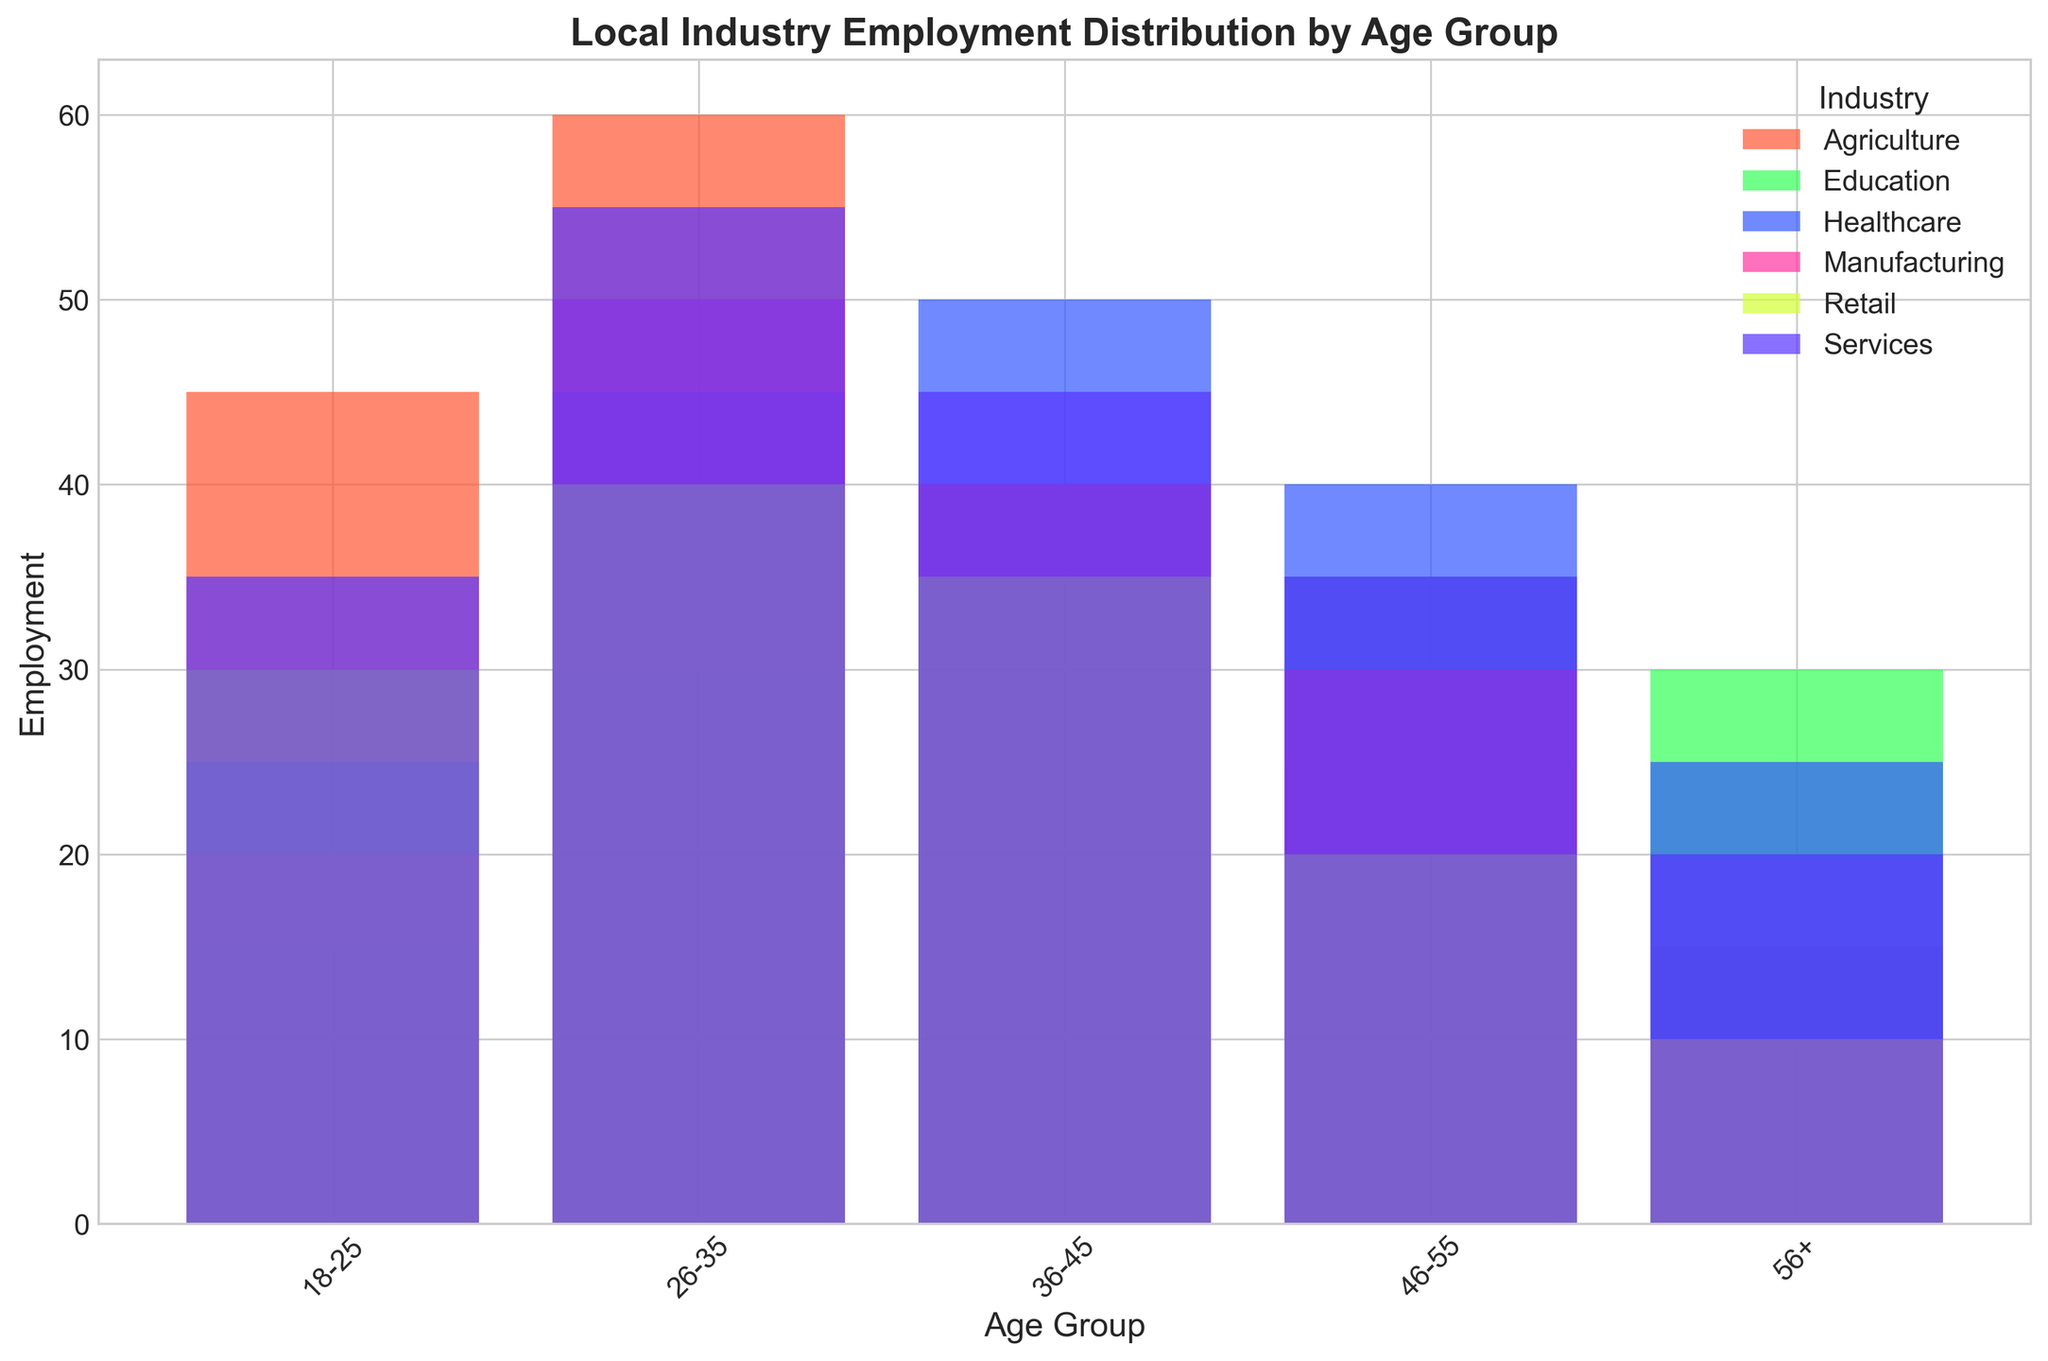What is the sum of employment in the Agriculture sector for the age groups 18-25 and 36-45? First, locate the bars representing the Agriculture sector for the age groups 18-25 and 36-45. The employment numbers are 45 and 35 respectively. Sum these values: 45 + 35 = 80.
Answer: 80 Which age group in the Services sector has the highest employment? Visually examine the height of the bars for each age group within the Services sector. The tallest bar represents the 26-35 age group, indicating the highest employment.
Answer: 26-35 What is the difference in employment between the Healthcare sector and Retail sector for the age group 56+? Identify the bars corresponding to the 56+ age group in both the Healthcare and Retail sectors. The employment values are 25 for Healthcare and 10 for Retail. Calculate the difference: 25 - 10 = 15.
Answer: 15 Which sector employs more people in the 46-55 age group: Manufacturing or Education? Compare the height of the bars for the 46-55 age group in both Manufacturing and Education. The employment numbers are 30 for Manufacturing and 35 for Education. Since 35 > 30, Education employs more people.
Answer: Education Among all the age groups, which industry has the lowest employment in the 18-25 age range? Look at the bars for the 18-25 age group across all industries. The shortest bar represents the Education sector, with an employment of 15.
Answer: Education What's the total number of people employed in the Manufacturing sector across all age groups? Add the employment numbers for all age groups in the Manufacturing sector: 20 (18-25) + 50 (26-35) + 40 (36-45) + 30 (46-55) + 10 (56+). Sum these values: 20 + 50 + 40 + 30 + 10 = 150.
Answer: 150 Which age group has the highest total employment across all sectors? Compare the total length of bars for each age group across all sectors. Summing each age group: 
  - 18-25: 45+20+35+30+25+15 = 170 
  - 26-35: 60+50+55+40+45+30 = 280 
  - 36-45: 35+40+45+35+50+40 = 245 
  - 46-55: 25+30+35+20+40+35 = 185 
  - 56+: 15+10+20+10+25+30 = 110 
The highest total is for the 26-35 age group.
Answer: 26-35 Which industry has the steepest decline in employment from the 26-35 age group to the 36-45 age group? Compare the differences between the employment numbers for the 26-35 and 36-45 age groups in all industries. The declines are: 
  - Agriculture: 60 - 35 = 25 
  - Manufacturing: 50 - 40 = 10 
  - Services: 55 - 45 = 10 
  - Retail: 40 - 35 = 5 
  - Healthcare: 45 - 50 = -5 (increase) 
  - Education: 30 - 40 = -10 (increase) 
The steepest decline is in the Agriculture sector.
Answer: Agriculture 